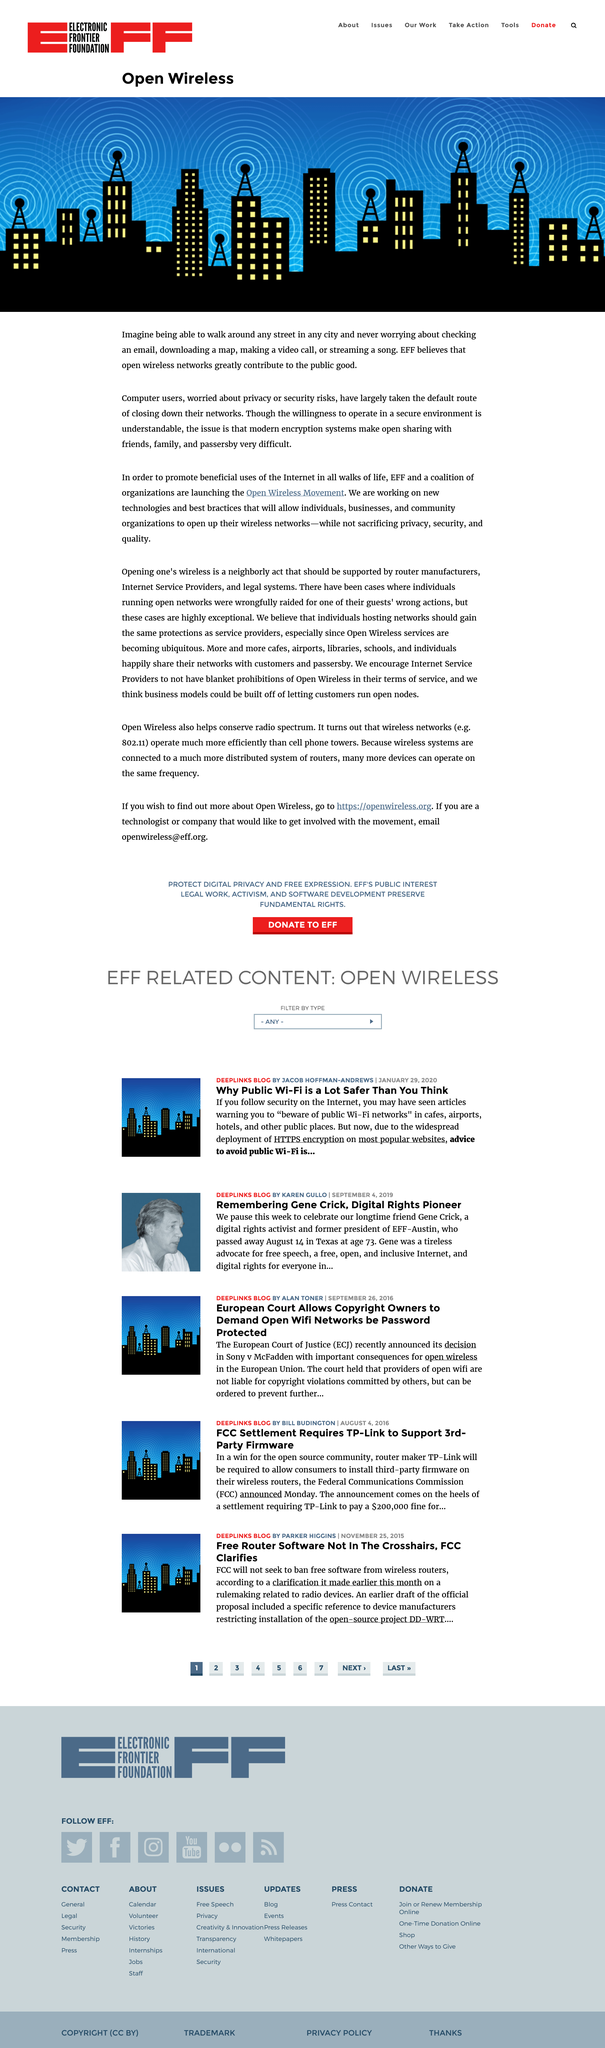Outline some significant characteristics in this image. We, the Electronic Frontier Foundation (EFF) and a coalition of organizations, are proud to announce the launch of the Open Wireless Movement. The purpose of this movement is to encourage the responsible and beneficial use of the Internet in all aspects of life. The Electronic Frontier Foundation (EFF) strongly believes that open wireless networks are a significant contributor to the public good. Modern encryption systems present an issue that makes open sharing with friends, family, and passerby very difficult. 